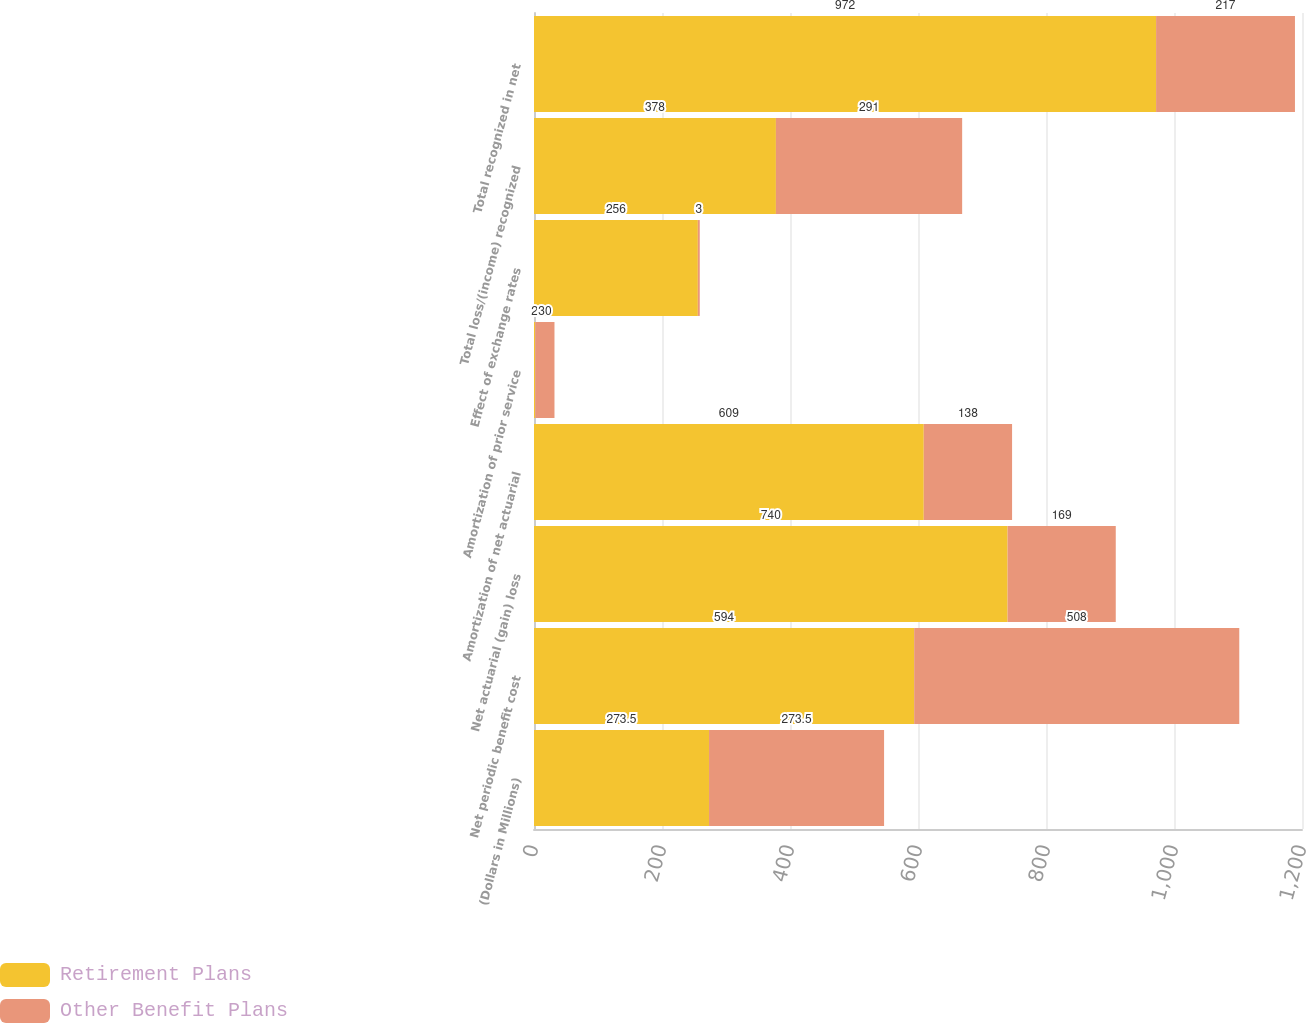<chart> <loc_0><loc_0><loc_500><loc_500><stacked_bar_chart><ecel><fcel>(Dollars in Millions)<fcel>Net periodic benefit cost<fcel>Net actuarial (gain) loss<fcel>Amortization of net actuarial<fcel>Amortization of prior service<fcel>Effect of exchange rates<fcel>Total loss/(income) recognized<fcel>Total recognized in net<nl><fcel>Retirement Plans<fcel>273.5<fcel>594<fcel>740<fcel>609<fcel>2<fcel>256<fcel>378<fcel>972<nl><fcel>Other Benefit Plans<fcel>273.5<fcel>508<fcel>169<fcel>138<fcel>30<fcel>3<fcel>291<fcel>217<nl></chart> 